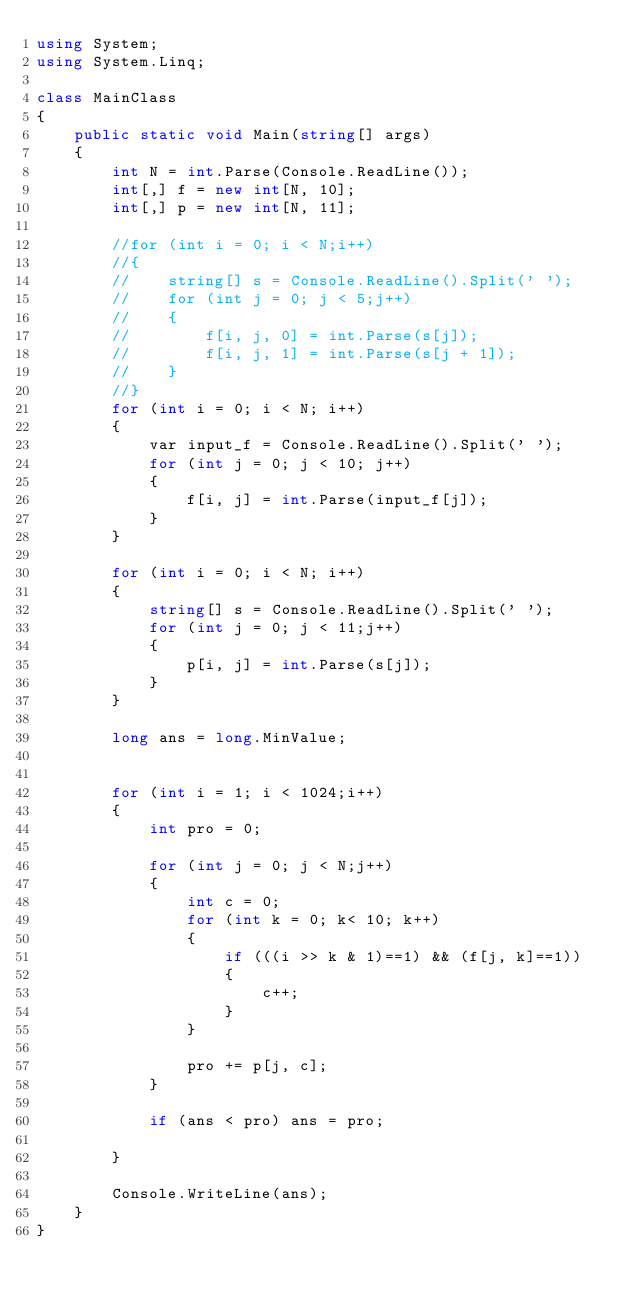<code> <loc_0><loc_0><loc_500><loc_500><_C#_>using System;
using System.Linq;

class MainClass
{
    public static void Main(string[] args)
    {
        int N = int.Parse(Console.ReadLine());
        int[,] f = new int[N, 10];
        int[,] p = new int[N, 11];

        //for (int i = 0; i < N;i++)
        //{
        //    string[] s = Console.ReadLine().Split(' ');
        //    for (int j = 0; j < 5;j++)
        //    {
        //        f[i, j, 0] = int.Parse(s[j]);
        //        f[i, j, 1] = int.Parse(s[j + 1]);
        //    }
        //}
        for (int i = 0; i < N; i++)
        {
            var input_f = Console.ReadLine().Split(' ');
            for (int j = 0; j < 10; j++)
            {
                f[i, j] = int.Parse(input_f[j]);
            }
        }

        for (int i = 0; i < N; i++)
        {
            string[] s = Console.ReadLine().Split(' ');
            for (int j = 0; j < 11;j++)
            {
                p[i, j] = int.Parse(s[j]);
            }
        }

        long ans = long.MinValue;


        for (int i = 1; i < 1024;i++)
        {
            int pro = 0;

            for (int j = 0; j < N;j++)
            {
                int c = 0;
                for (int k = 0; k< 10; k++)
                {
                    if (((i >> k & 1)==1) && (f[j, k]==1))
                    {
                        c++;
                    }
                }

                pro += p[j, c];
            }

            if (ans < pro) ans = pro;

        }

        Console.WriteLine(ans);
    }
}</code> 